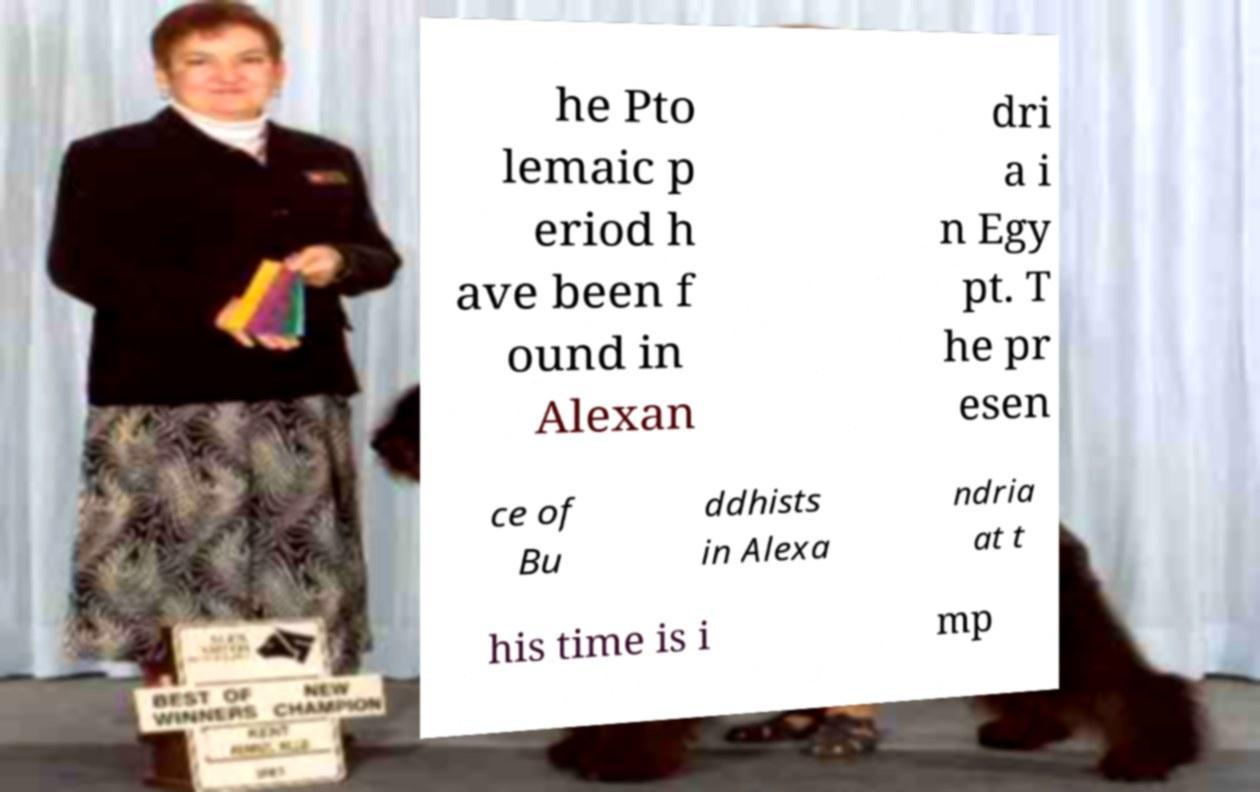There's text embedded in this image that I need extracted. Can you transcribe it verbatim? he Pto lemaic p eriod h ave been f ound in Alexan dri a i n Egy pt. T he pr esen ce of Bu ddhists in Alexa ndria at t his time is i mp 